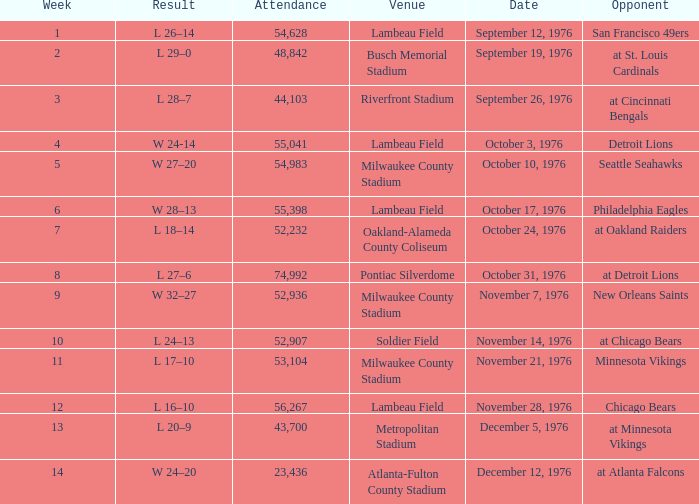How many people attended the game on September 19, 1976? 1.0. 